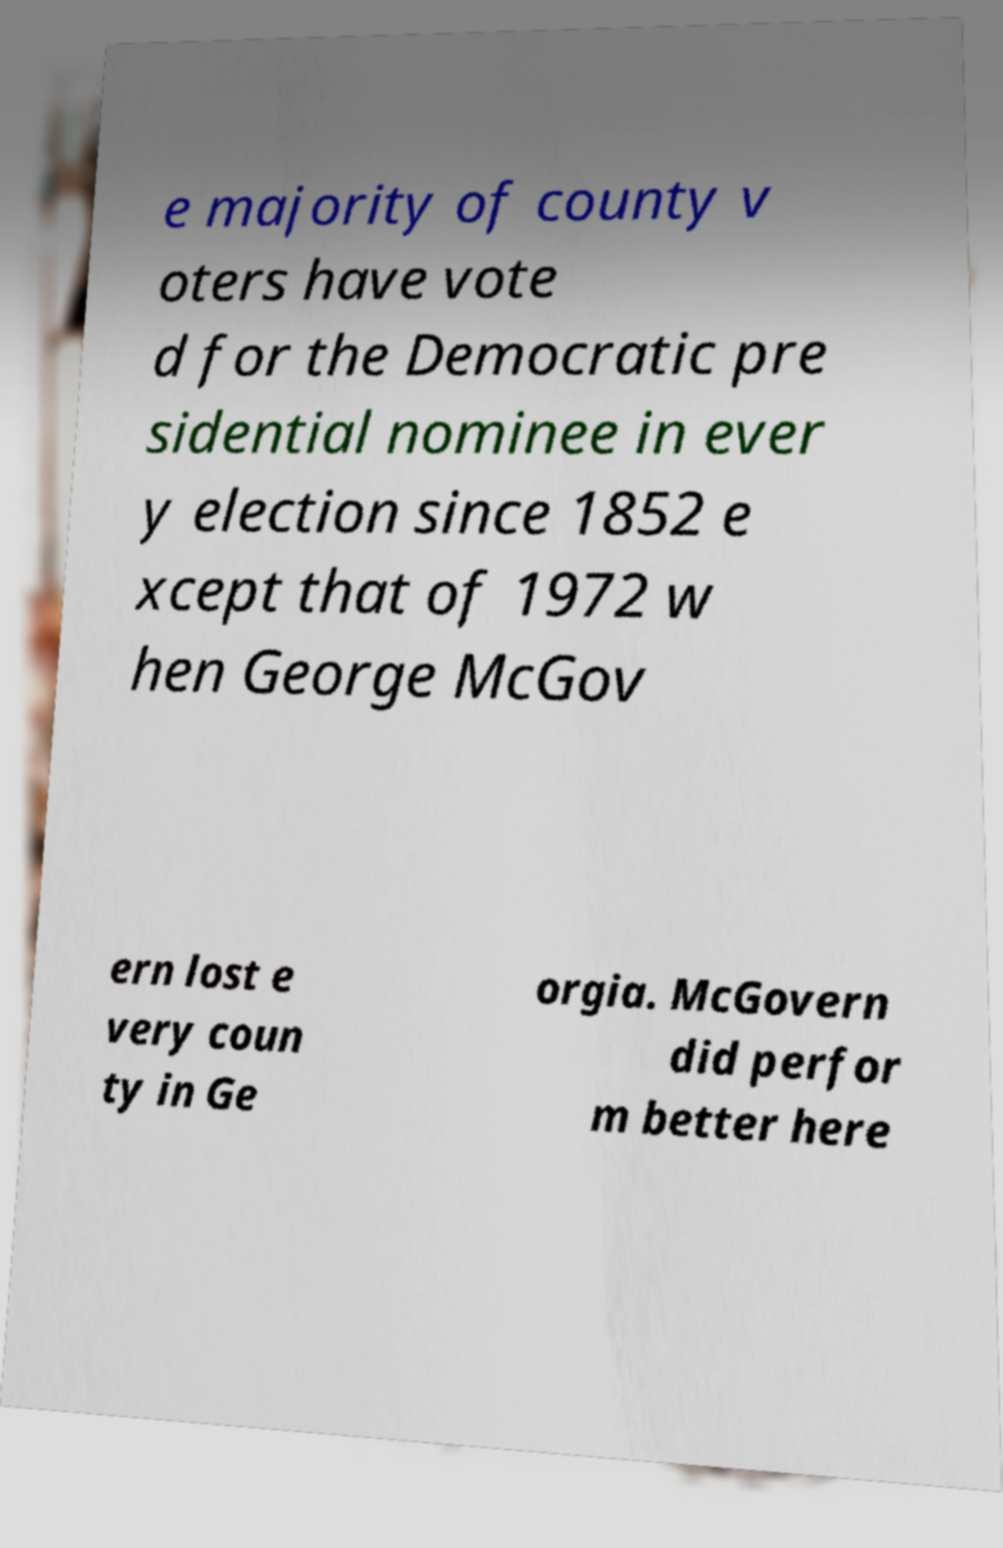I need the written content from this picture converted into text. Can you do that? e majority of county v oters have vote d for the Democratic pre sidential nominee in ever y election since 1852 e xcept that of 1972 w hen George McGov ern lost e very coun ty in Ge orgia. McGovern did perfor m better here 